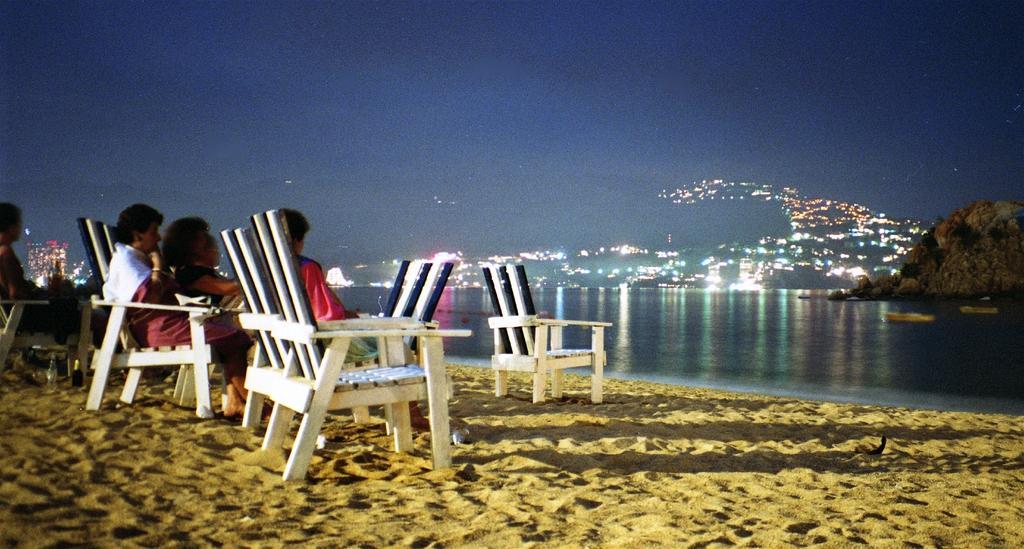What are the persons in the image doing? The persons in the image are sitting on chairs. What type of surface are the chairs placed on? The chairs are on sand. What can be seen in the background of the image? There is water and lights visible in the background. What type of locket is hanging from the balloon in the image? There is no balloon or locket present in the image. What kind of trouble are the persons facing in the image? The persons in the image are not facing any trouble; they are sitting on chairs in a relaxed setting. 